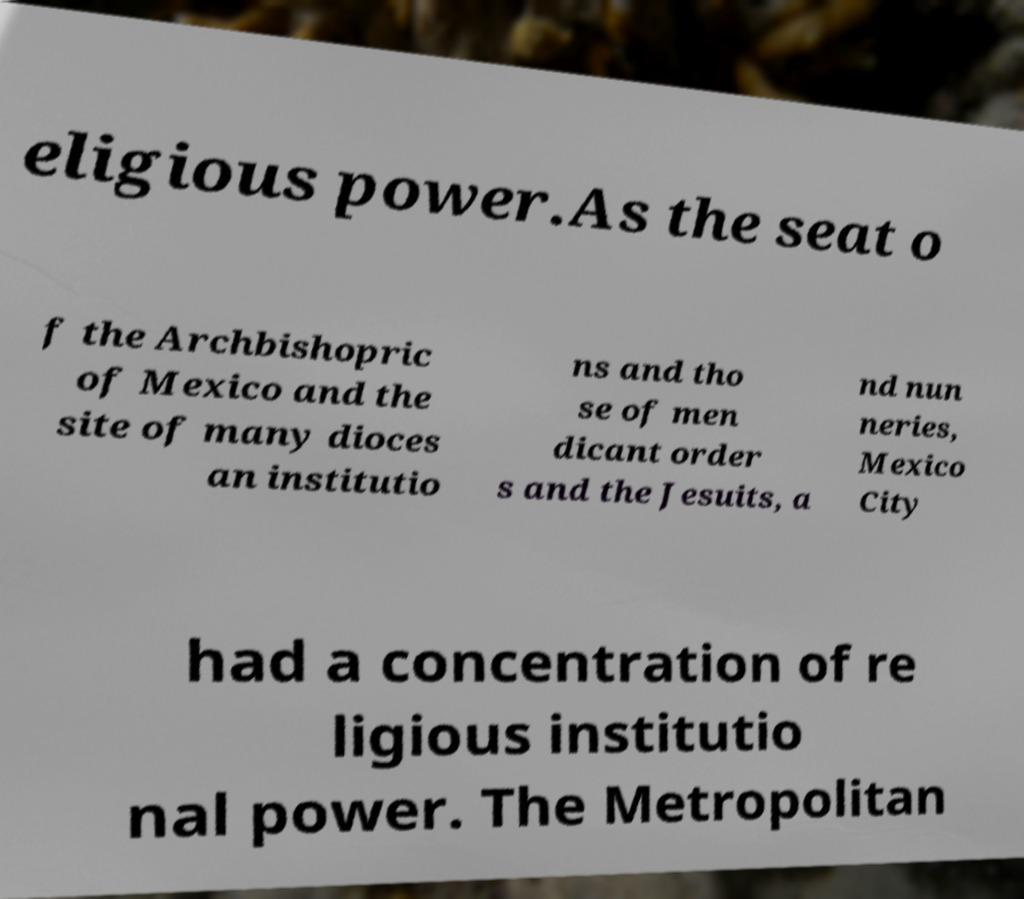There's text embedded in this image that I need extracted. Can you transcribe it verbatim? eligious power.As the seat o f the Archbishopric of Mexico and the site of many dioces an institutio ns and tho se of men dicant order s and the Jesuits, a nd nun neries, Mexico City had a concentration of re ligious institutio nal power. The Metropolitan 